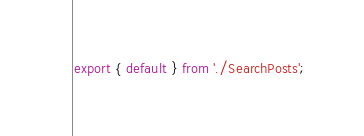Convert code to text. <code><loc_0><loc_0><loc_500><loc_500><_JavaScript_>export { default } from './SearchPosts';
</code> 